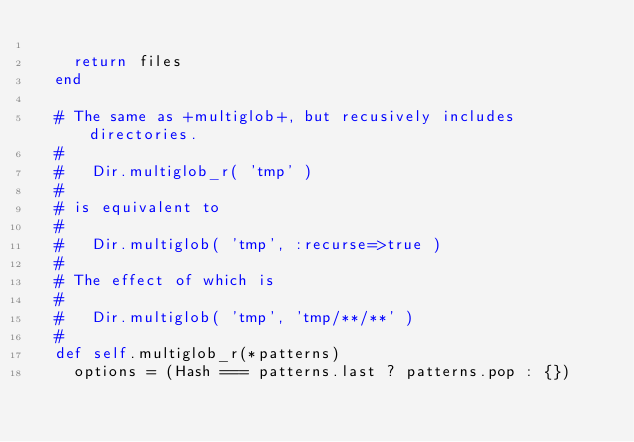<code> <loc_0><loc_0><loc_500><loc_500><_Ruby_>
    return files
  end

  # The same as +multiglob+, but recusively includes directories.
  #
  #   Dir.multiglob_r( 'tmp' )
  #
  # is equivalent to
  #
  #   Dir.multiglob( 'tmp', :recurse=>true )
  #
  # The effect of which is
  #
  #   Dir.multiglob( 'tmp', 'tmp/**/**' )
  #
  def self.multiglob_r(*patterns)
    options = (Hash === patterns.last ? patterns.pop : {})</code> 